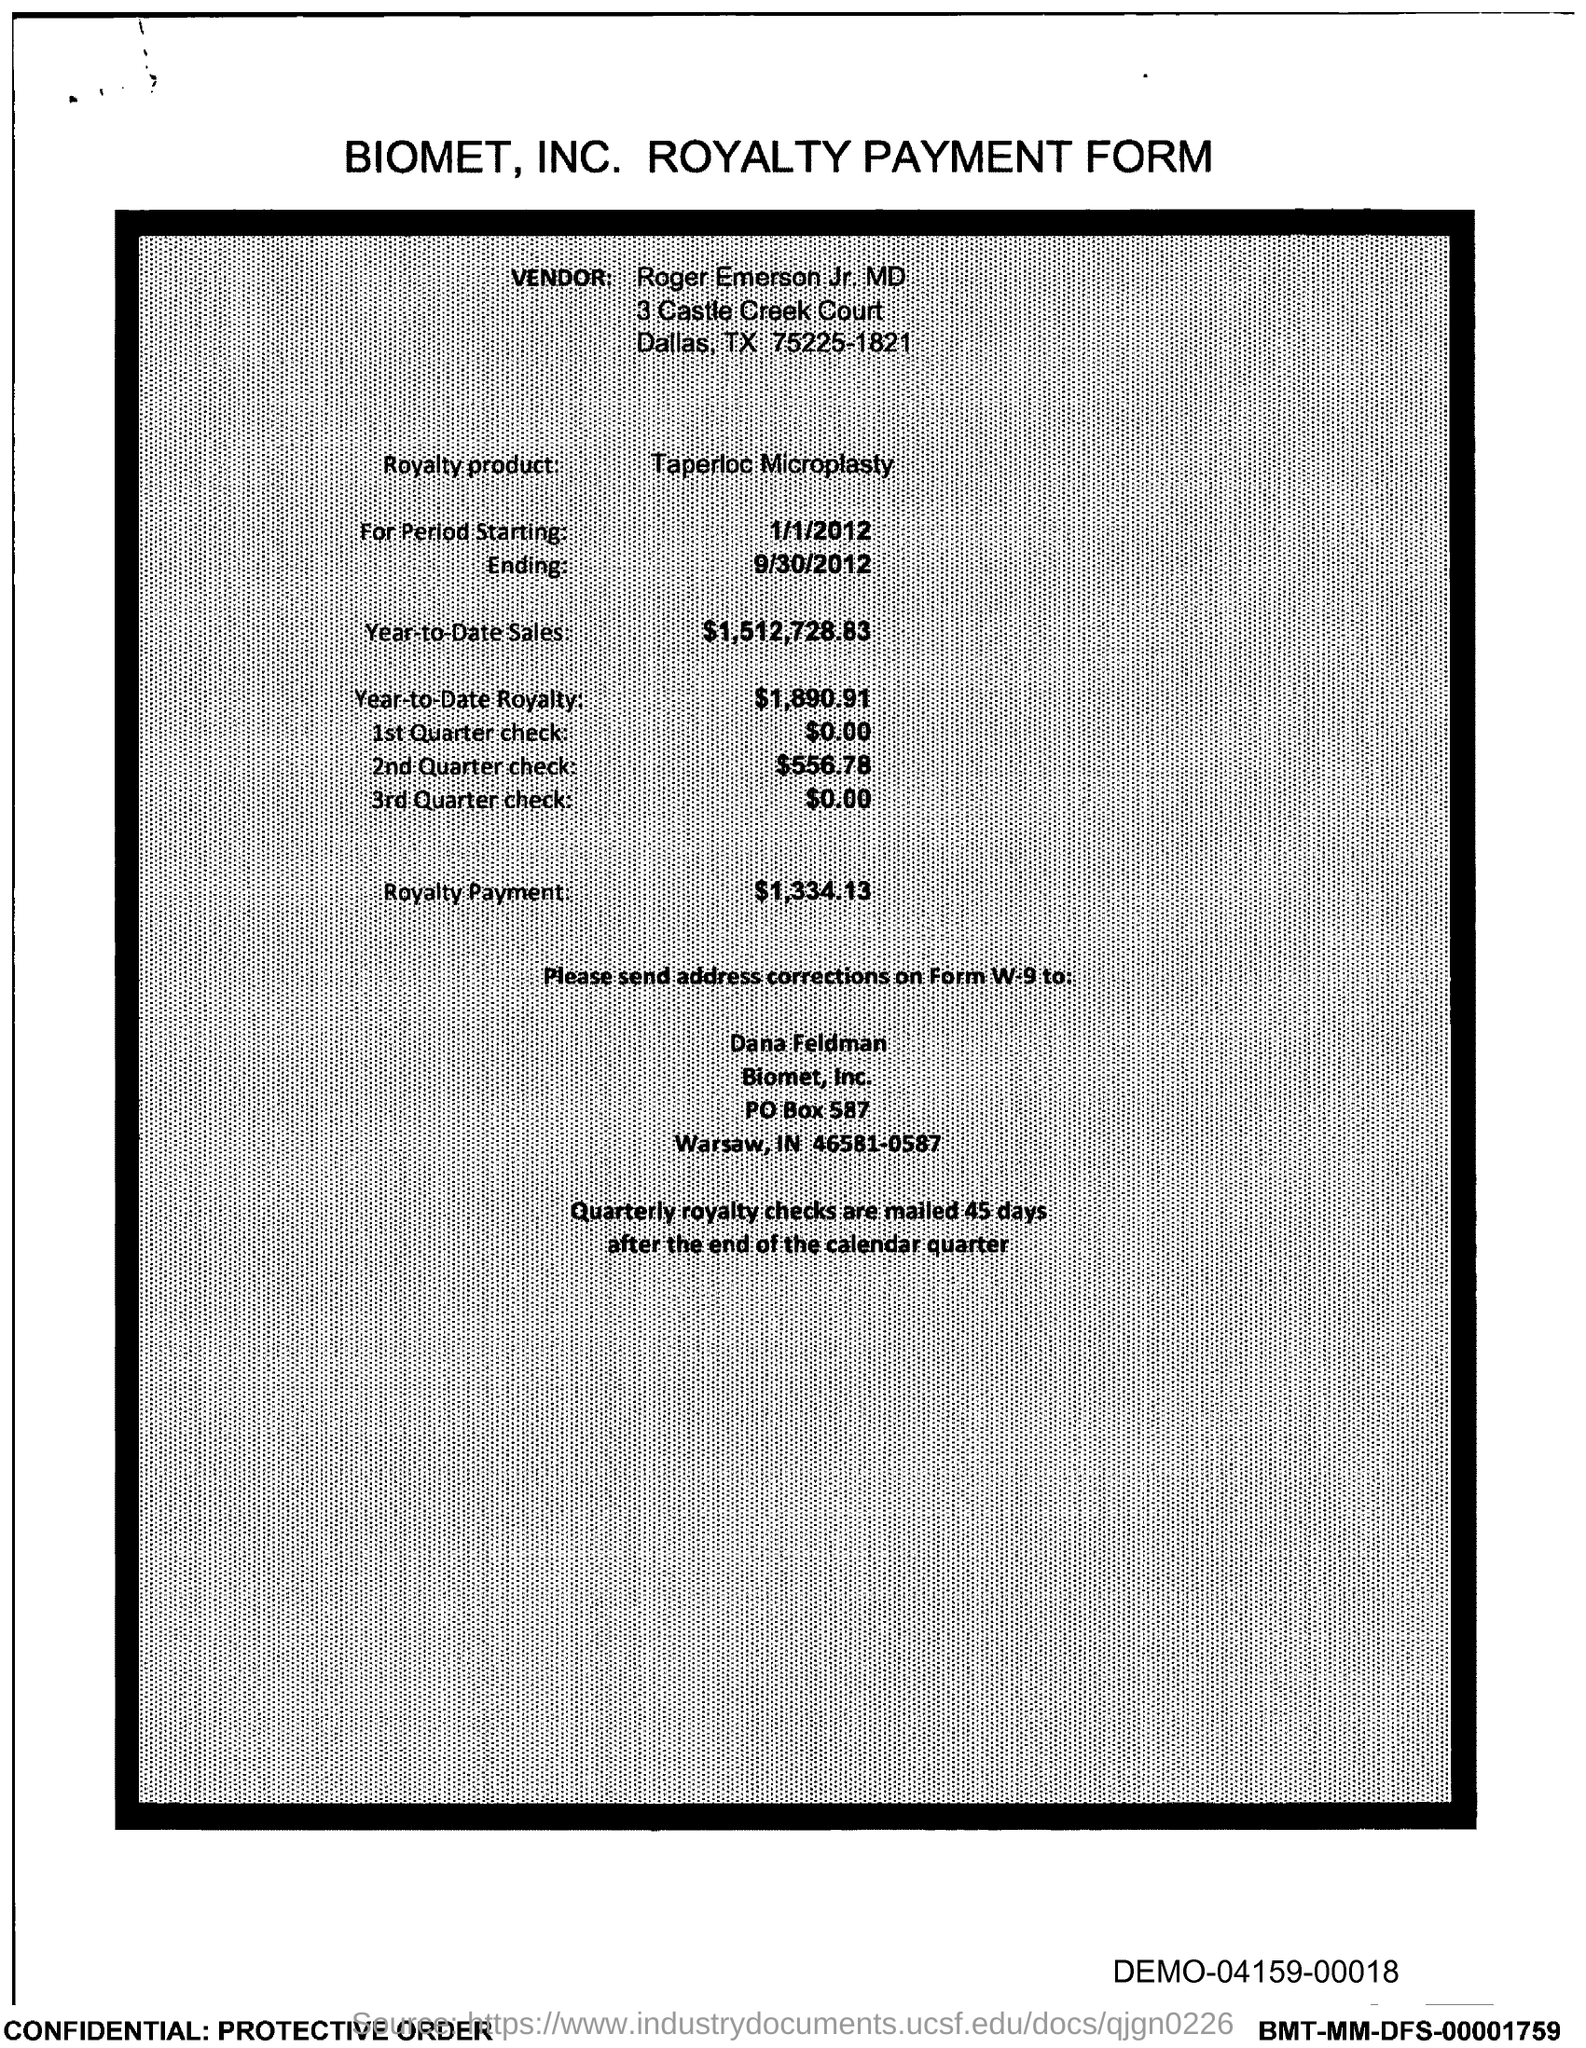What is the vendor name given in the form?
Provide a succinct answer. Roger Emerson Jr. MD. Which royalty product is mentioned in the form?
Your response must be concise. Taperloc Microplasty. What is the Year-to-Date Sales of the royalty product?
Provide a short and direct response. $1,512,728.83. What is the Year-to-Date royalty of the product?
Keep it short and to the point. $1,890.91. What is the amount of 1st quarter check mentioned in the form?
Ensure brevity in your answer.  $0.00. What is the amount of 2nd quarter check mentioned in the form?
Your response must be concise. $556.78. What is the royalty payment of the product mentioned in the form?
Make the answer very short. $1,334.13. What is the start date of the royalty period?
Your answer should be very brief. 1/1/2012. 